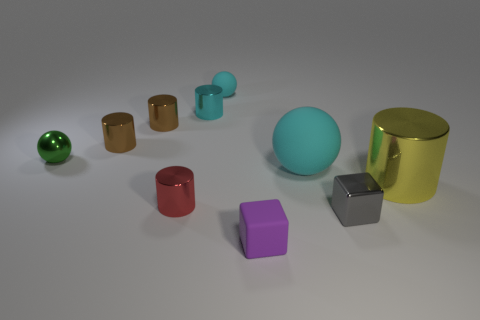There is a matte ball in front of the green ball; how big is it?
Ensure brevity in your answer.  Large. Does the green thing have the same size as the red metal cylinder?
Make the answer very short. Yes. Is the number of cyan metal things that are in front of the tiny red thing less than the number of small purple rubber objects on the left side of the gray metallic object?
Keep it short and to the point. Yes. What is the size of the matte thing that is in front of the green shiny ball and behind the tiny red shiny thing?
Offer a terse response. Large. There is a large object that is in front of the cyan object right of the purple thing; is there a yellow object that is to the right of it?
Give a very brief answer. No. Are any big metal cylinders visible?
Ensure brevity in your answer.  Yes. Are there more tiny purple matte objects that are behind the tiny green ball than purple objects behind the purple thing?
Provide a succinct answer. No. What is the size of the other ball that is made of the same material as the large ball?
Your answer should be compact. Small. There is a cyan matte ball on the right side of the tiny rubber object in front of the block that is to the right of the large cyan rubber thing; what size is it?
Give a very brief answer. Large. There is a sphere to the right of the tiny purple matte cube; what color is it?
Provide a succinct answer. Cyan. 